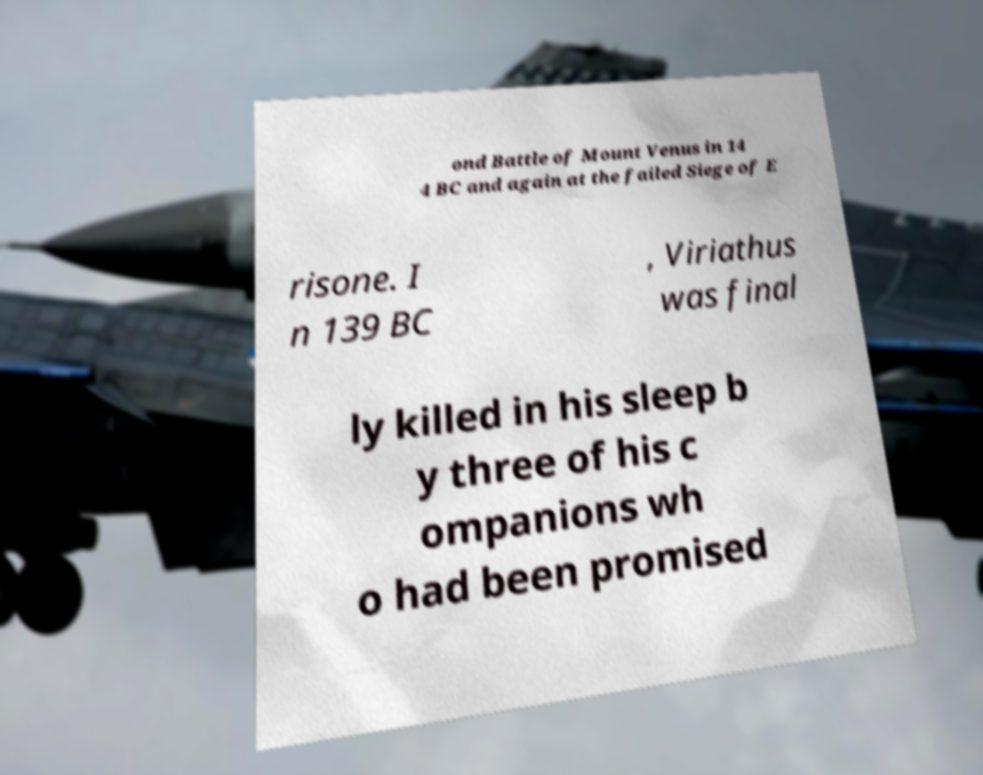What messages or text are displayed in this image? I need them in a readable, typed format. ond Battle of Mount Venus in 14 4 BC and again at the failed Siege of E risone. I n 139 BC , Viriathus was final ly killed in his sleep b y three of his c ompanions wh o had been promised 